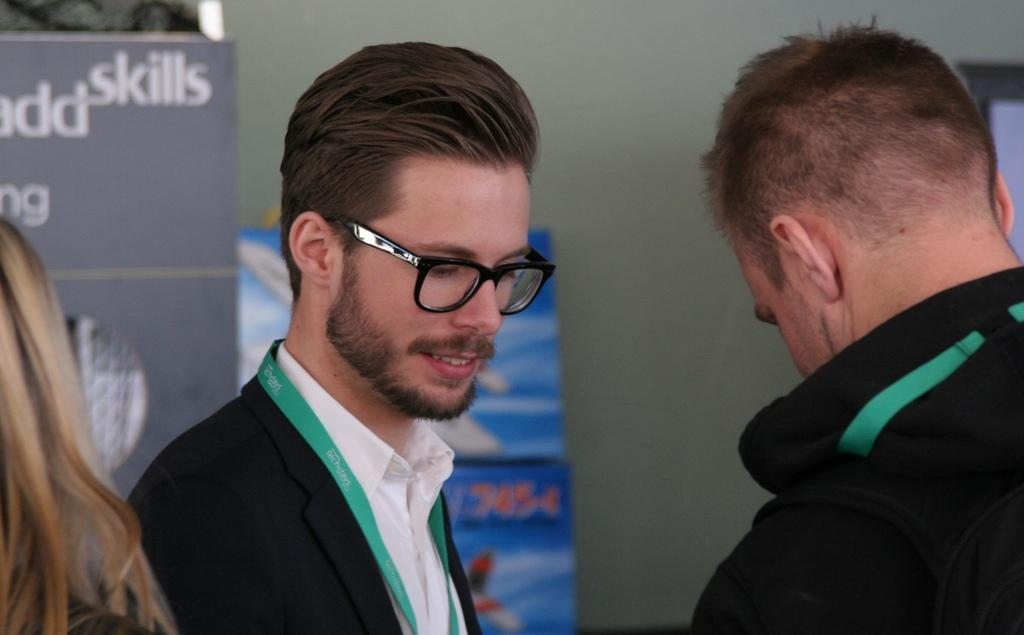How many people are in the image? There are two persons in the image. What can be seen on the left side of the image? The hair of a person is visible on the left side of the image. What is visible in the background of the image? There are hoardings and a wall in the background of the image. Can you tell me how many donkeys are present in the image? There are no donkeys present in the image. What type of brush is being used by the person on the left side of the image? There is no brush visible in the image; only the hair of a person is visible on the left side. 